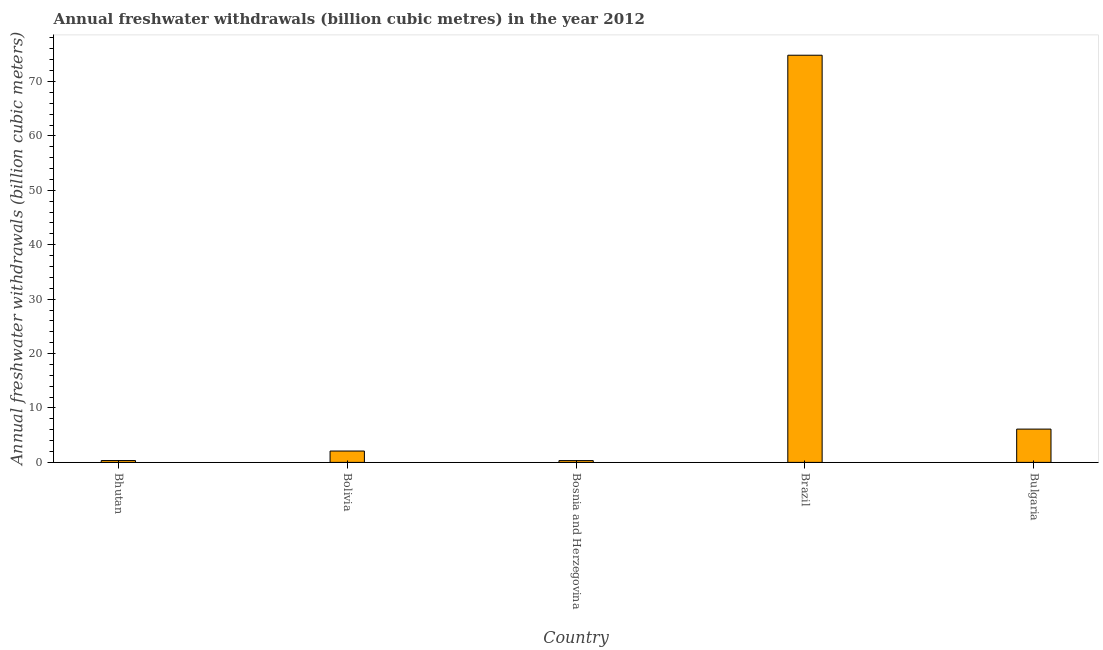Does the graph contain grids?
Your response must be concise. No. What is the title of the graph?
Give a very brief answer. Annual freshwater withdrawals (billion cubic metres) in the year 2012. What is the label or title of the Y-axis?
Provide a short and direct response. Annual freshwater withdrawals (billion cubic meters). What is the annual freshwater withdrawals in Bolivia?
Keep it short and to the point. 2.09. Across all countries, what is the maximum annual freshwater withdrawals?
Your answer should be compact. 74.83. Across all countries, what is the minimum annual freshwater withdrawals?
Keep it short and to the point. 0.33. In which country was the annual freshwater withdrawals minimum?
Keep it short and to the point. Bosnia and Herzegovina. What is the sum of the annual freshwater withdrawals?
Your answer should be compact. 83.7. What is the difference between the annual freshwater withdrawals in Bolivia and Bulgaria?
Give a very brief answer. -4.03. What is the average annual freshwater withdrawals per country?
Your answer should be compact. 16.74. What is the median annual freshwater withdrawals?
Keep it short and to the point. 2.09. In how many countries, is the annual freshwater withdrawals greater than 54 billion cubic meters?
Give a very brief answer. 1. Is the annual freshwater withdrawals in Bolivia less than that in Bulgaria?
Your answer should be compact. Yes. What is the difference between the highest and the second highest annual freshwater withdrawals?
Provide a succinct answer. 68.71. Is the sum of the annual freshwater withdrawals in Bolivia and Bosnia and Herzegovina greater than the maximum annual freshwater withdrawals across all countries?
Your response must be concise. No. What is the difference between the highest and the lowest annual freshwater withdrawals?
Offer a very short reply. 74.5. In how many countries, is the annual freshwater withdrawals greater than the average annual freshwater withdrawals taken over all countries?
Make the answer very short. 1. How many bars are there?
Offer a terse response. 5. Are all the bars in the graph horizontal?
Offer a very short reply. No. How many countries are there in the graph?
Your response must be concise. 5. What is the difference between two consecutive major ticks on the Y-axis?
Offer a terse response. 10. What is the Annual freshwater withdrawals (billion cubic meters) of Bhutan?
Make the answer very short. 0.34. What is the Annual freshwater withdrawals (billion cubic meters) in Bolivia?
Your response must be concise. 2.09. What is the Annual freshwater withdrawals (billion cubic meters) of Bosnia and Herzegovina?
Give a very brief answer. 0.33. What is the Annual freshwater withdrawals (billion cubic meters) of Brazil?
Ensure brevity in your answer.  74.83. What is the Annual freshwater withdrawals (billion cubic meters) of Bulgaria?
Offer a very short reply. 6.12. What is the difference between the Annual freshwater withdrawals (billion cubic meters) in Bhutan and Bolivia?
Offer a terse response. -1.75. What is the difference between the Annual freshwater withdrawals (billion cubic meters) in Bhutan and Bosnia and Herzegovina?
Ensure brevity in your answer.  0.01. What is the difference between the Annual freshwater withdrawals (billion cubic meters) in Bhutan and Brazil?
Your answer should be very brief. -74.49. What is the difference between the Annual freshwater withdrawals (billion cubic meters) in Bhutan and Bulgaria?
Your answer should be compact. -5.78. What is the difference between the Annual freshwater withdrawals (billion cubic meters) in Bolivia and Bosnia and Herzegovina?
Your response must be concise. 1.76. What is the difference between the Annual freshwater withdrawals (billion cubic meters) in Bolivia and Brazil?
Provide a short and direct response. -72.74. What is the difference between the Annual freshwater withdrawals (billion cubic meters) in Bolivia and Bulgaria?
Give a very brief answer. -4.03. What is the difference between the Annual freshwater withdrawals (billion cubic meters) in Bosnia and Herzegovina and Brazil?
Your answer should be very brief. -74.5. What is the difference between the Annual freshwater withdrawals (billion cubic meters) in Bosnia and Herzegovina and Bulgaria?
Your answer should be very brief. -5.79. What is the difference between the Annual freshwater withdrawals (billion cubic meters) in Brazil and Bulgaria?
Your answer should be compact. 68.71. What is the ratio of the Annual freshwater withdrawals (billion cubic meters) in Bhutan to that in Bolivia?
Provide a short and direct response. 0.16. What is the ratio of the Annual freshwater withdrawals (billion cubic meters) in Bhutan to that in Brazil?
Provide a short and direct response. 0.01. What is the ratio of the Annual freshwater withdrawals (billion cubic meters) in Bhutan to that in Bulgaria?
Keep it short and to the point. 0.06. What is the ratio of the Annual freshwater withdrawals (billion cubic meters) in Bolivia to that in Bosnia and Herzegovina?
Your answer should be compact. 6.35. What is the ratio of the Annual freshwater withdrawals (billion cubic meters) in Bolivia to that in Brazil?
Offer a very short reply. 0.03. What is the ratio of the Annual freshwater withdrawals (billion cubic meters) in Bolivia to that in Bulgaria?
Keep it short and to the point. 0.34. What is the ratio of the Annual freshwater withdrawals (billion cubic meters) in Bosnia and Herzegovina to that in Brazil?
Offer a terse response. 0. What is the ratio of the Annual freshwater withdrawals (billion cubic meters) in Bosnia and Herzegovina to that in Bulgaria?
Keep it short and to the point. 0.05. What is the ratio of the Annual freshwater withdrawals (billion cubic meters) in Brazil to that in Bulgaria?
Your answer should be very brief. 12.23. 